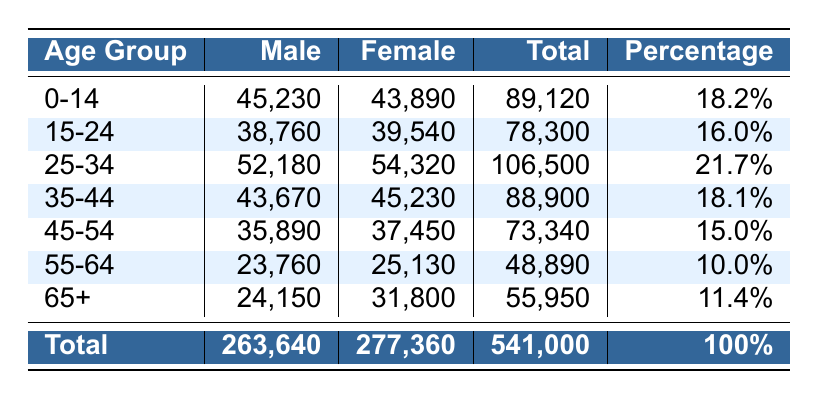What is the total population of the city? By looking at the 'Total' row at the bottom of the table, we can see that the total population is 541,000.
Answer: 541,000 How many more females are there than males in the 25-34 age group? The number of females in the 25-34 age group is 54,320 and the number of males is 52,180. So, 54,320 - 52,180 = 2,140 more females than males.
Answer: 2,140 What percentage of the population is aged 55-64? The table indicates that the population percentage for the 55-64 age group is 10%.
Answer: 10% Does the 35-44 age group have a larger total population than the 15-24 age group? The total for 35-44 is 88,900 and for 15-24 it is 78,300. Since 88,900 is greater than 78,300, the 35-44 age group does have a larger population.
Answer: Yes What is the combined population of the 0-14 and 65+ age groups? The total for 0-14 is 89,120 and for 65+ it is 55,950. Adding them gives 89,120 + 55,950 = 145,070.
Answer: 145,070 Is the ratio of males to females in the overall population approximately 1:1? The male population is 263,640 and the female population is 277,360. The ratio is about 0.95:1, which is not approximately equal to 1:1.
Answer: No Which age group has the highest population percentage? Looking at the 'Percentage' column, the 25-34 age group, with a percentage of 21.7%, has the highest population percentage.
Answer: 25-34 What is the average number of males in the age groups 45-54 and 55-64? The number of males in 45-54 is 35,890 and in 55-64 it is 23,760. The average is (35,890 + 23,760) / 2 = 29,825.
Answer: 29,825 How many total people are in the 15-24 age group? The total population for the 15-24 age group as indicated in the table is 78,300.
Answer: 78,300 In which age group is the population for males less than 25,000? The 55-64 age group has 23,760 males, which is less than 25,000.
Answer: 55-64 